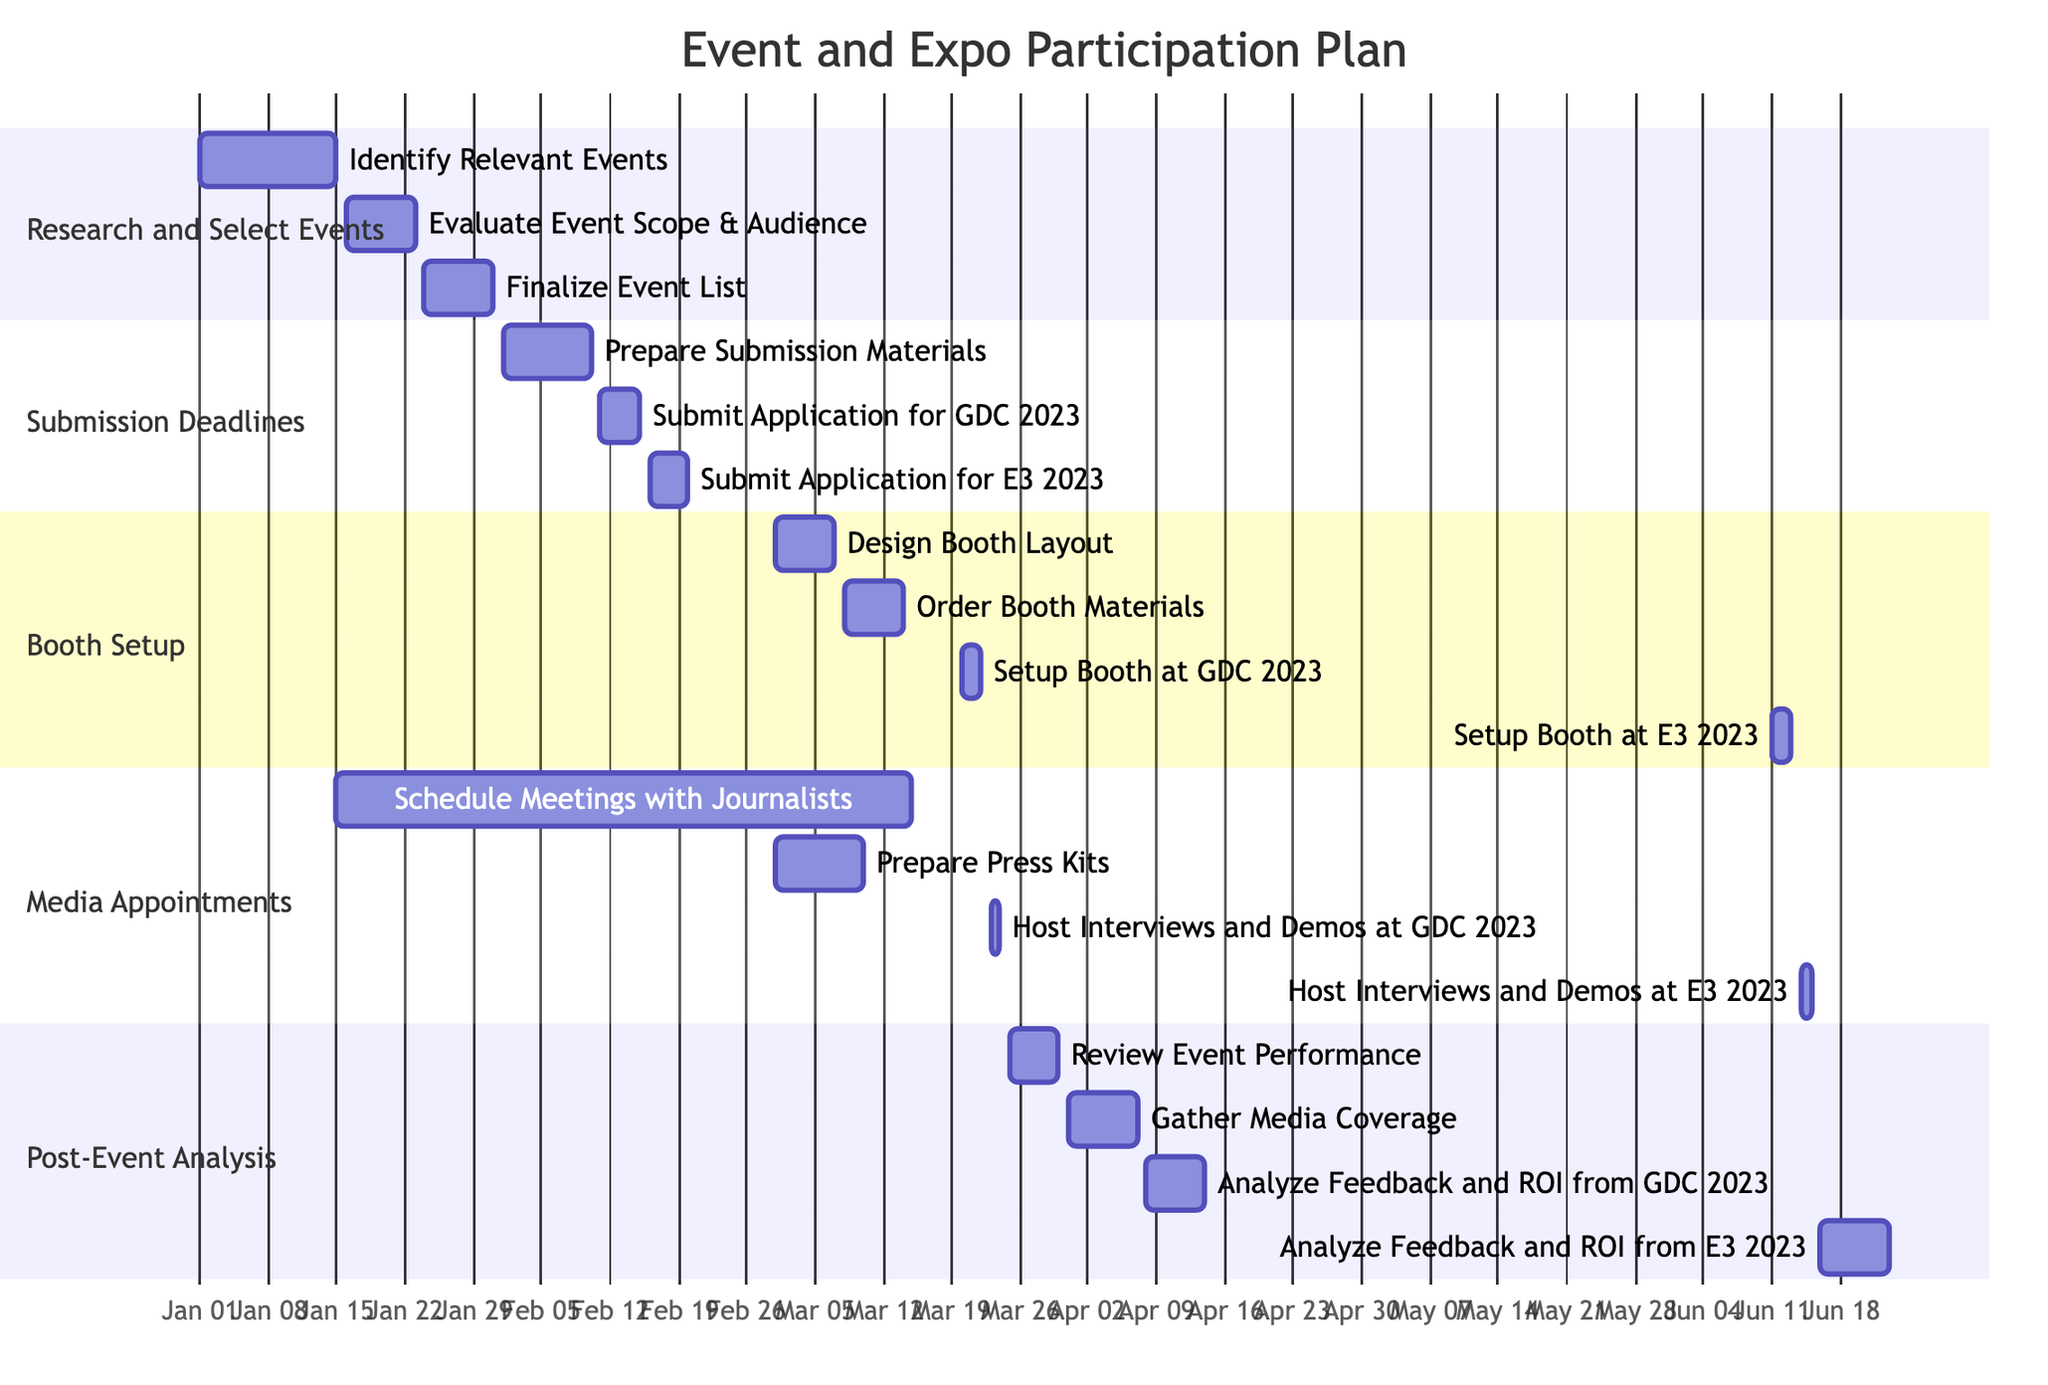What is the end date for the task "Evaluate Event Scope & Audience"? The task "Evaluate Event Scope & Audience" has an end date of January 23, 2023, which is directly indicated in the diagram.
Answer: January 23, 2023 How many tasks are included in the "Booth Setup" section? The "Booth Setup" section contains four tasks: "Design Booth Layout," "Order Booth Materials," "Setup Booth at GDC 2023," and "Setup Booth at E3 2023." Thus, the total is four tasks.
Answer: 4 What is the start date for the task "Gather Media Coverage"? The task "Gather Media Coverage" starts on March 31, 2023, as specified in the diagram.
Answer: March 31, 2023 Which task in the "Media Appointments" section has the latest end date? In the "Media Appointments" section, the task "Host Interviews and Demos at E3 2023" has the latest end date of June 15, 2023, when compared to the other tasks in that section.
Answer: June 15, 2023 What are the tasks that occur before the "Setup Booth at E3 2023"? The tasks that occur before "Setup Booth at E3 2023" are: "Design Booth Layout," "Order Booth Materials," "Setup Booth at GDC 2023," and several media appointment tasks. This includes both submission and media-related activities leading up to the event.
Answer: Design Booth Layout, Order Booth Materials, Setup Booth at GDC 2023, Schedule Meetings with Journalists, Prepare Press Kits, Host Interviews and Demos at GDC 2023 What is the duration of "Post-Event Analysis" tasks overall? The "Post-Event Analysis" tasks occur from March 25, 2023, to June 23, 2023. This spans a total of 90 days, calculated by counting the days between the start of the first task and the end of the last task in this section.
Answer: 90 days How many days span between the "Submit Application for GDC 2023" and "Setup Booth at GDC 2023"? The "Submit Application for GDC 2023" ends on February 15, 2023, and the "Setup Booth at GDC 2023" starts on March 20, 2023. Therefore, the time span between these two tasks is 33 days.
Answer: 33 days What is the earliest start date across all sections? The earliest start date across all sections is January 1, 2023, corresponding to the "Identify Relevant Events" task in the "Research and Select Events" section of the diagram.
Answer: January 1, 2023 What is the start date of the "Host Interviews and Demos at GDC 2023" task? The "Host Interviews and Demos at GDC 2023" task begins on March 23, 2023, as shown in the chart.
Answer: March 23, 2023 